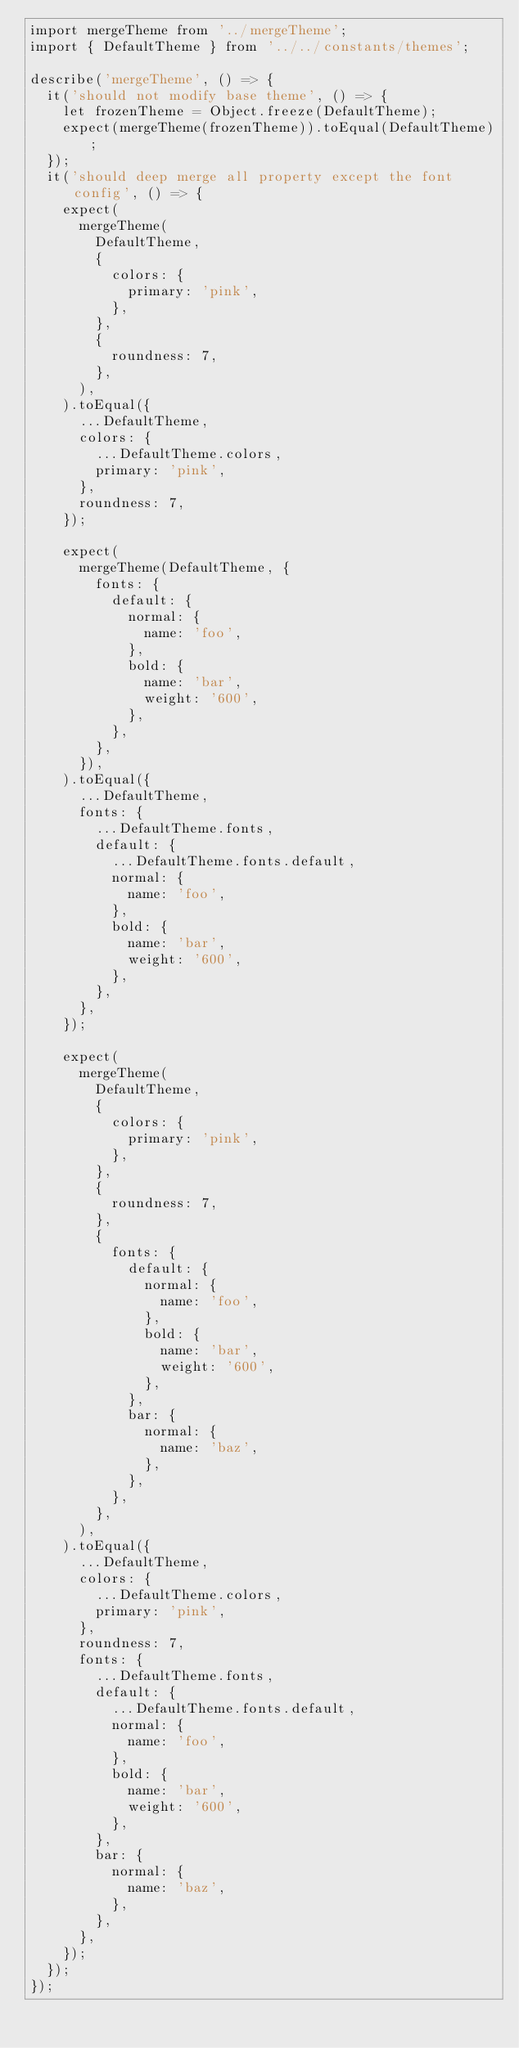Convert code to text. <code><loc_0><loc_0><loc_500><loc_500><_TypeScript_>import mergeTheme from '../mergeTheme';
import { DefaultTheme } from '../../constants/themes';

describe('mergeTheme', () => {
  it('should not modify base theme', () => {
    let frozenTheme = Object.freeze(DefaultTheme);
    expect(mergeTheme(frozenTheme)).toEqual(DefaultTheme);
  });
  it('should deep merge all property except the font config', () => {
    expect(
      mergeTheme(
        DefaultTheme,
        {
          colors: {
            primary: 'pink',
          },
        },
        {
          roundness: 7,
        },
      ),
    ).toEqual({
      ...DefaultTheme,
      colors: {
        ...DefaultTheme.colors,
        primary: 'pink',
      },
      roundness: 7,
    });

    expect(
      mergeTheme(DefaultTheme, {
        fonts: {
          default: {
            normal: {
              name: 'foo',
            },
            bold: {
              name: 'bar',
              weight: '600',
            },
          },
        },
      }),
    ).toEqual({
      ...DefaultTheme,
      fonts: {
        ...DefaultTheme.fonts,
        default: {
          ...DefaultTheme.fonts.default,
          normal: {
            name: 'foo',
          },
          bold: {
            name: 'bar',
            weight: '600',
          },
        },
      },
    });

    expect(
      mergeTheme(
        DefaultTheme,
        {
          colors: {
            primary: 'pink',
          },
        },
        {
          roundness: 7,
        },
        {
          fonts: {
            default: {
              normal: {
                name: 'foo',
              },
              bold: {
                name: 'bar',
                weight: '600',
              },
            },
            bar: {
              normal: {
                name: 'baz',
              },
            },
          },
        },
      ),
    ).toEqual({
      ...DefaultTheme,
      colors: {
        ...DefaultTheme.colors,
        primary: 'pink',
      },
      roundness: 7,
      fonts: {
        ...DefaultTheme.fonts,
        default: {
          ...DefaultTheme.fonts.default,
          normal: {
            name: 'foo',
          },
          bold: {
            name: 'bar',
            weight: '600',
          },
        },
        bar: {
          normal: {
            name: 'baz',
          },
        },
      },
    });
  });
});
</code> 